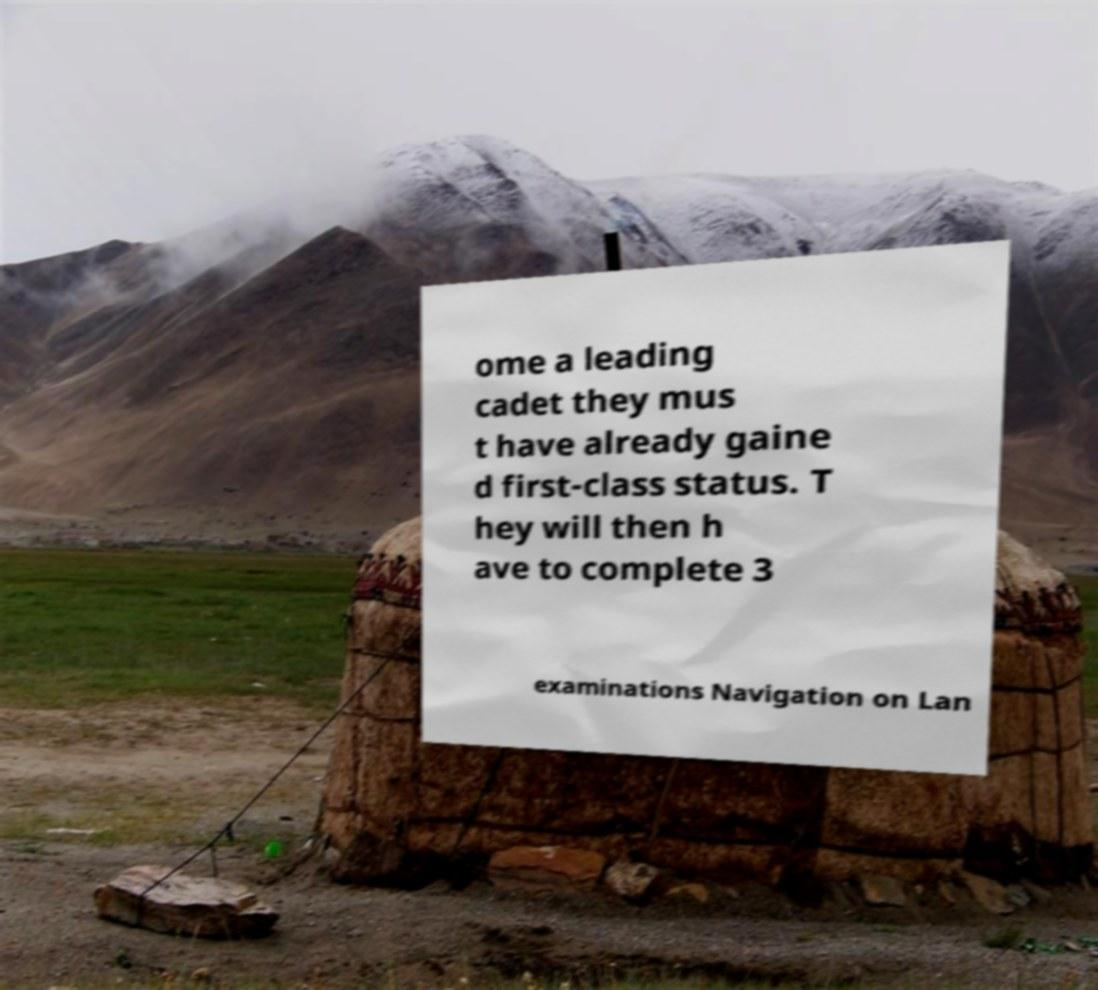Can you accurately transcribe the text from the provided image for me? ome a leading cadet they mus t have already gaine d first-class status. T hey will then h ave to complete 3 examinations Navigation on Lan 